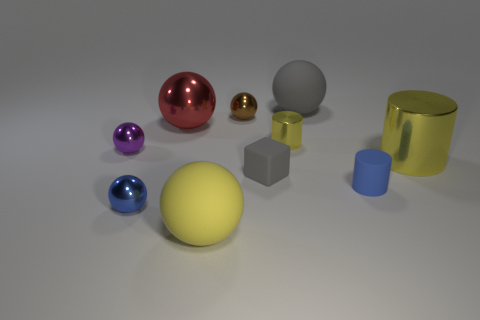Is there anything else that has the same material as the small gray block?
Keep it short and to the point. Yes. There is a big gray thing that is the same shape as the tiny blue metallic object; what is it made of?
Provide a succinct answer. Rubber. Are there an equal number of large yellow metal cylinders that are in front of the big cylinder and small red things?
Offer a terse response. Yes. How big is the ball that is both in front of the small purple metallic object and left of the big red ball?
Your answer should be very brief. Small. Is there anything else that is the same color as the small matte block?
Provide a succinct answer. Yes. What size is the yellow matte thing that is in front of the tiny metal ball in front of the purple shiny sphere?
Make the answer very short. Large. There is a tiny sphere that is to the right of the tiny purple shiny thing and on the left side of the brown object; what is its color?
Your answer should be very brief. Blue. How many other things are there of the same size as the brown metallic thing?
Ensure brevity in your answer.  5. There is a gray sphere; is its size the same as the metallic cylinder that is to the left of the big cylinder?
Make the answer very short. No. The metal sphere that is the same size as the yellow matte object is what color?
Your response must be concise. Red. 